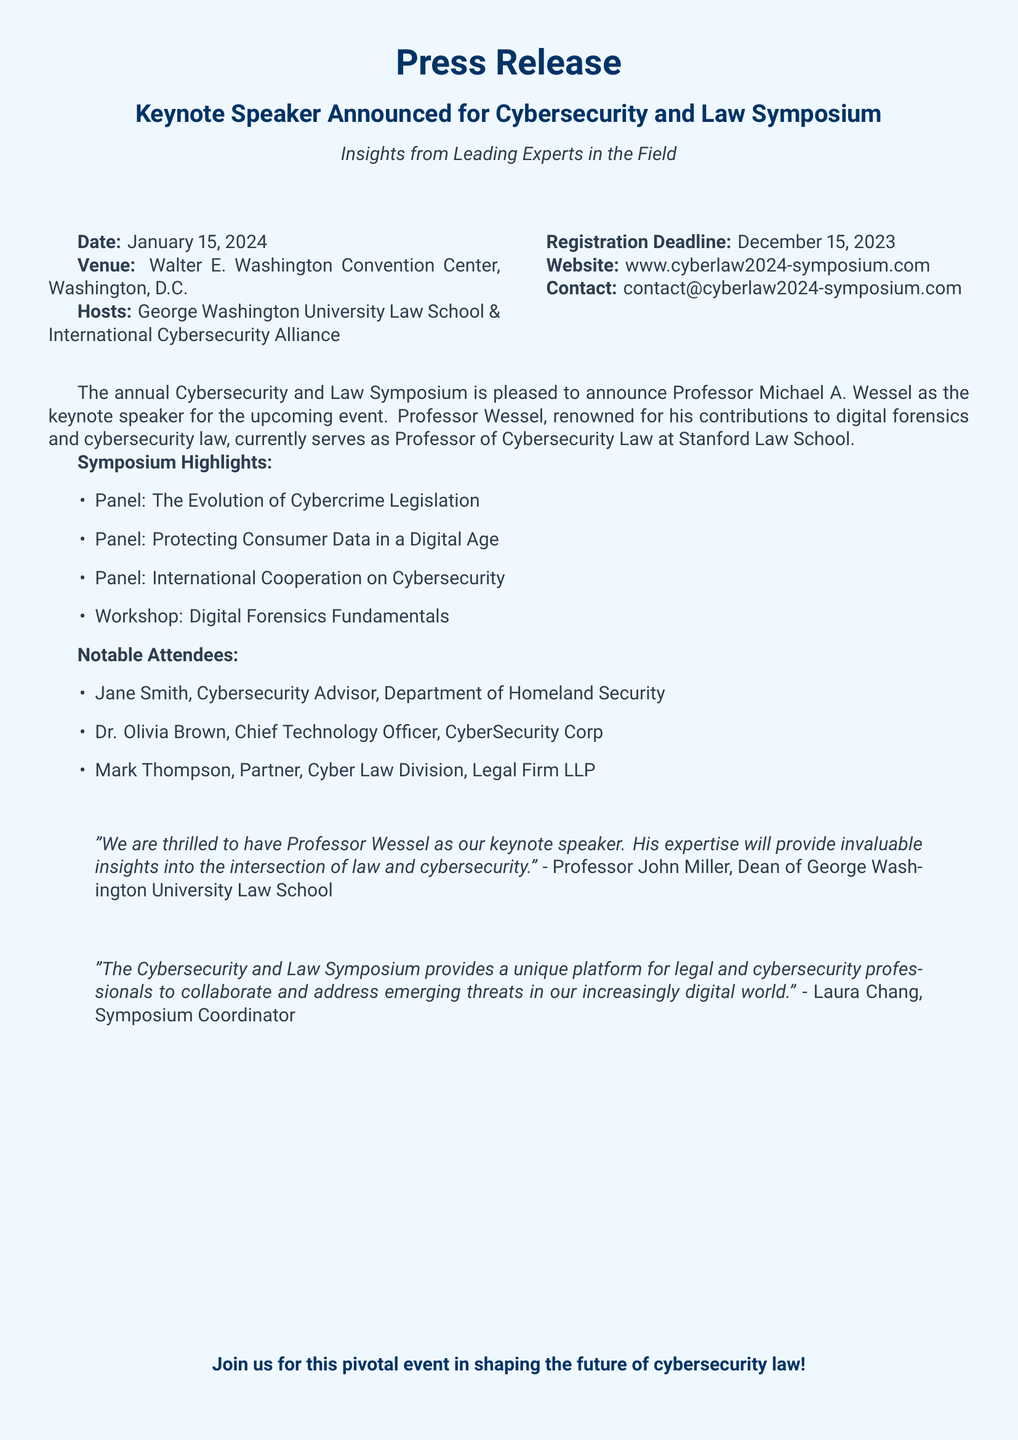What is the date of the symposium? The document specifies the event date as January 15, 2024.
Answer: January 15, 2024 Who is the keynote speaker? The keynote speaker announced in the document is Professor Michael A. Wessel.
Answer: Professor Michael A. Wessel Which university is hosting the symposium? The press release mentions that George Washington University Law School is one of the hosts.
Answer: George Washington University Law School What is the registration deadline? The document states the registration deadline as December 15, 2023.
Answer: December 15, 2023 What is the venue for the event? The venue mentioned in the document is the Walter E. Washington Convention Center, Washington, D.C.
Answer: Walter E. Washington Convention Center, Washington, D.C What is one of the panel topics? The press release lists several panel topics, one of which is "The Evolution of Cybercrime Legislation."
Answer: The Evolution of Cybercrime Legislation Who is the Symposium Coordinator? Laura Chang is cited as the Symposium Coordinator in the document.
Answer: Laura Chang How many notable attendees are listed? The document enumerates three notable attendees in the list provided.
Answer: Three 